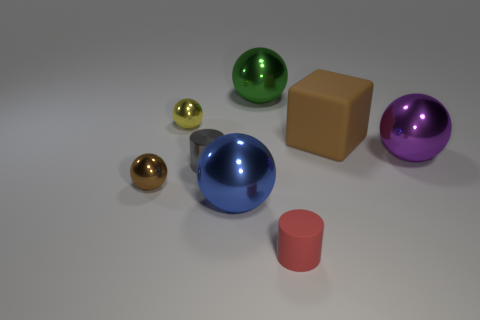There is a tiny metallic thing right of the tiny yellow thing; what is its shape?
Give a very brief answer. Cylinder. There is a big block that is made of the same material as the red thing; what is its color?
Keep it short and to the point. Brown. What material is the other thing that is the same shape as the gray shiny object?
Your answer should be very brief. Rubber. What is the shape of the tiny yellow shiny thing?
Your answer should be very brief. Sphere. There is a thing that is on the right side of the green sphere and on the left side of the big matte object; what is its material?
Keep it short and to the point. Rubber. What is the shape of the gray object that is the same material as the small yellow thing?
Your answer should be compact. Cylinder. What size is the cylinder that is made of the same material as the yellow thing?
Your answer should be very brief. Small. There is a object that is right of the green sphere and in front of the small gray metal object; what is its shape?
Your answer should be compact. Cylinder. There is a cylinder that is in front of the big sphere in front of the small gray cylinder; how big is it?
Offer a terse response. Small. How many other things are the same color as the matte cube?
Make the answer very short. 1. 